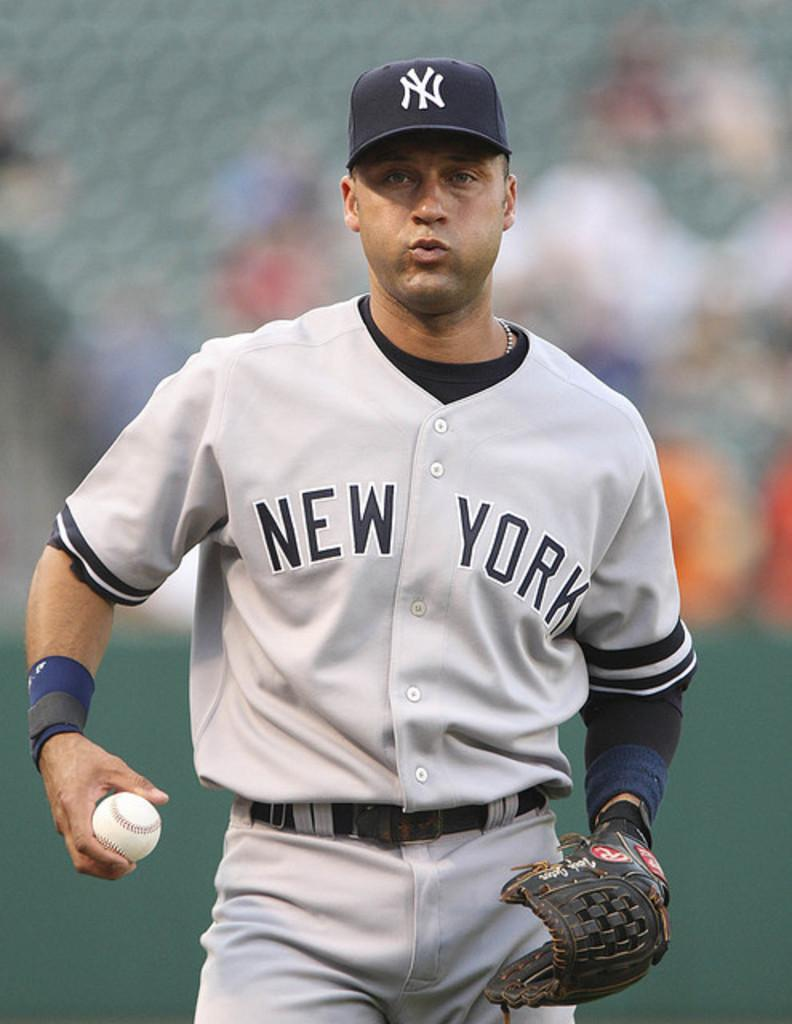<image>
Give a short and clear explanation of the subsequent image. Baseball player for New York getting ready to pitch. 